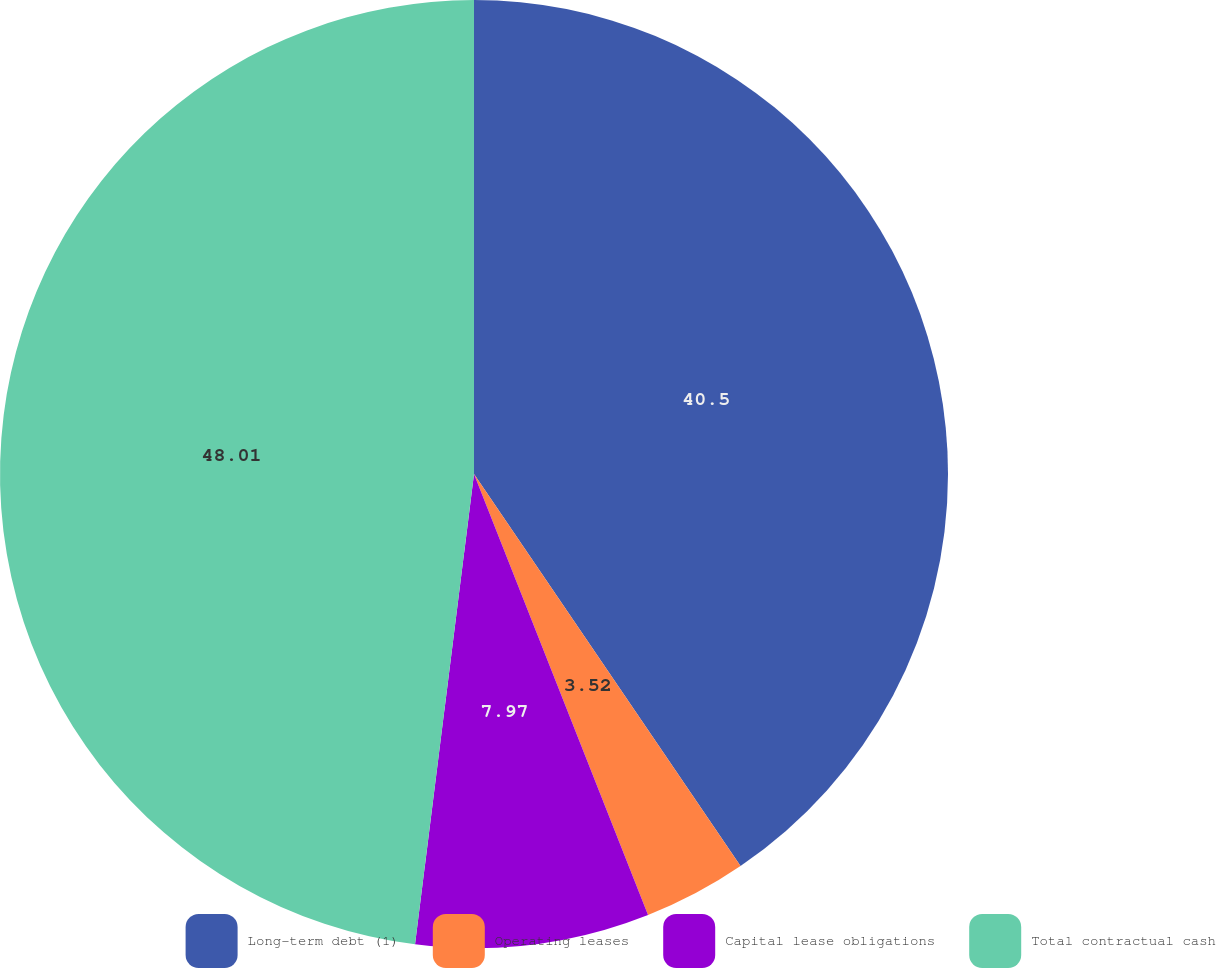Convert chart to OTSL. <chart><loc_0><loc_0><loc_500><loc_500><pie_chart><fcel>Long-term debt (1)<fcel>Operating leases<fcel>Capital lease obligations<fcel>Total contractual cash<nl><fcel>40.5%<fcel>3.52%<fcel>7.97%<fcel>48.02%<nl></chart> 